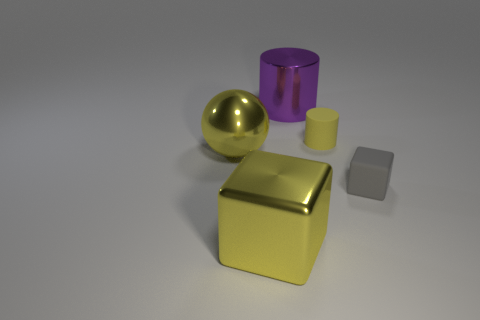How many large purple cylinders are there?
Provide a short and direct response. 1. How many tiny matte things are both in front of the yellow matte object and behind the small gray object?
Offer a terse response. 0. What is the tiny yellow cylinder made of?
Provide a succinct answer. Rubber. Is there a large blue rubber thing?
Your answer should be compact. No. What is the color of the large metallic object left of the big shiny cube?
Provide a succinct answer. Yellow. How many gray objects are to the right of the big purple object behind the yellow thing that is behind the big yellow sphere?
Make the answer very short. 1. What is the material of the yellow object that is to the right of the big yellow sphere and in front of the small yellow rubber cylinder?
Provide a succinct answer. Metal. Does the large yellow sphere have the same material as the yellow object in front of the gray matte thing?
Offer a very short reply. Yes. Is the number of matte blocks to the left of the small yellow matte cylinder greater than the number of spheres that are on the left side of the purple metallic thing?
Your answer should be very brief. No. What is the shape of the small gray matte object?
Your answer should be very brief. Cube. 